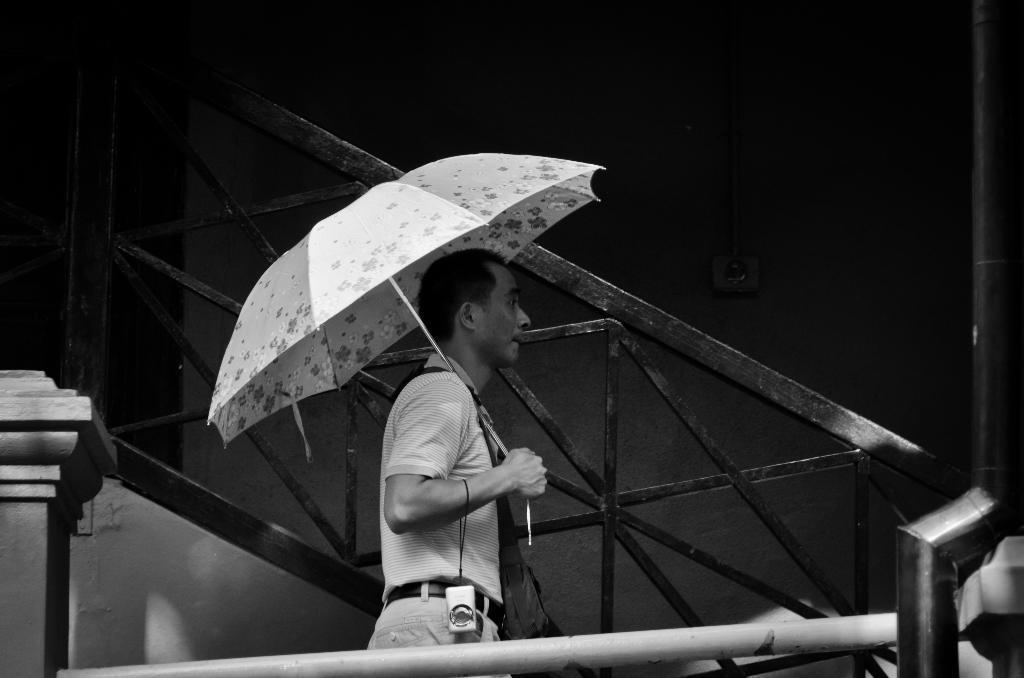Could you give a brief overview of what you see in this image? In this image I can see a man is standing and I can see he is holding an umbrella. I can also see a camera over here. I can see this image is black and white in colour. 